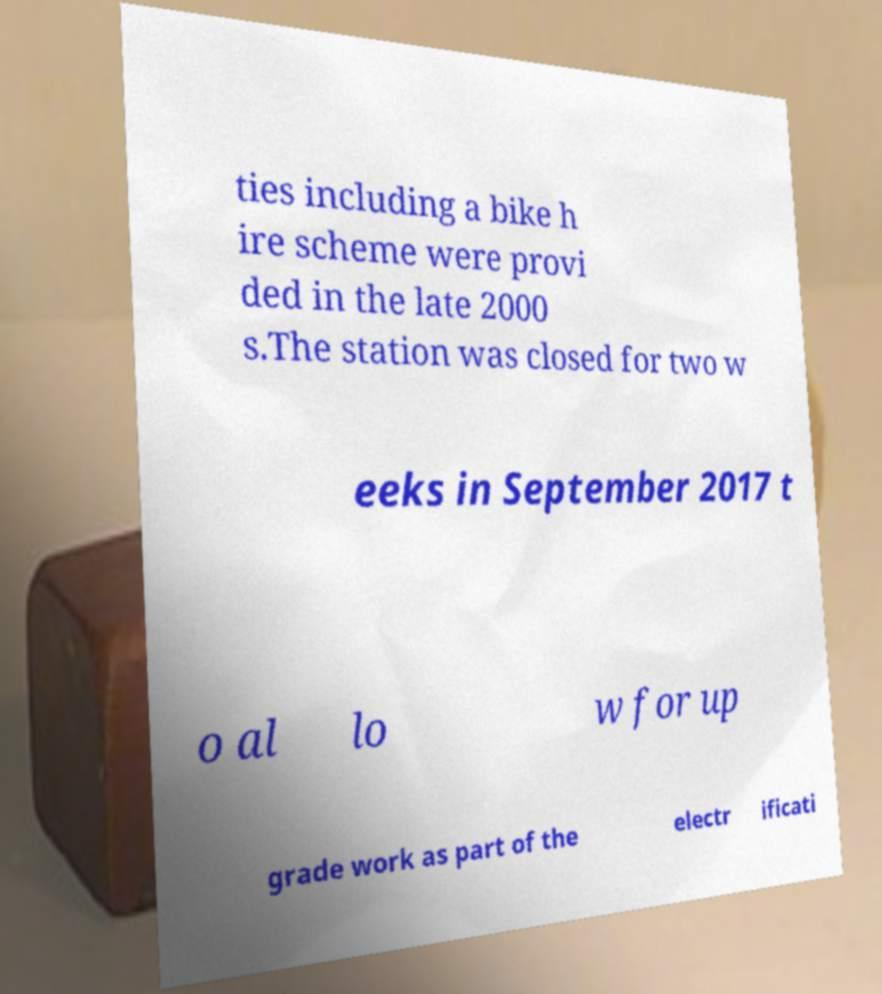What messages or text are displayed in this image? I need them in a readable, typed format. ties including a bike h ire scheme were provi ded in the late 2000 s.The station was closed for two w eeks in September 2017 t o al lo w for up grade work as part of the electr ificati 